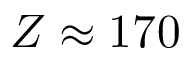Convert formula to latex. <formula><loc_0><loc_0><loc_500><loc_500>Z \approx 1 7 0</formula> 